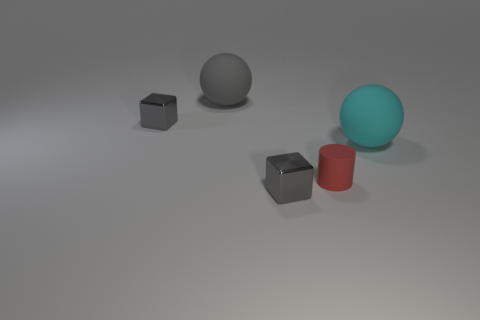Add 3 tiny red rubber things. How many objects exist? 8 Subtract all balls. How many objects are left? 3 Subtract 0 yellow spheres. How many objects are left? 5 Subtract all big spheres. Subtract all small things. How many objects are left? 0 Add 5 big cyan matte spheres. How many big cyan matte spheres are left? 6 Add 1 tiny gray objects. How many tiny gray objects exist? 3 